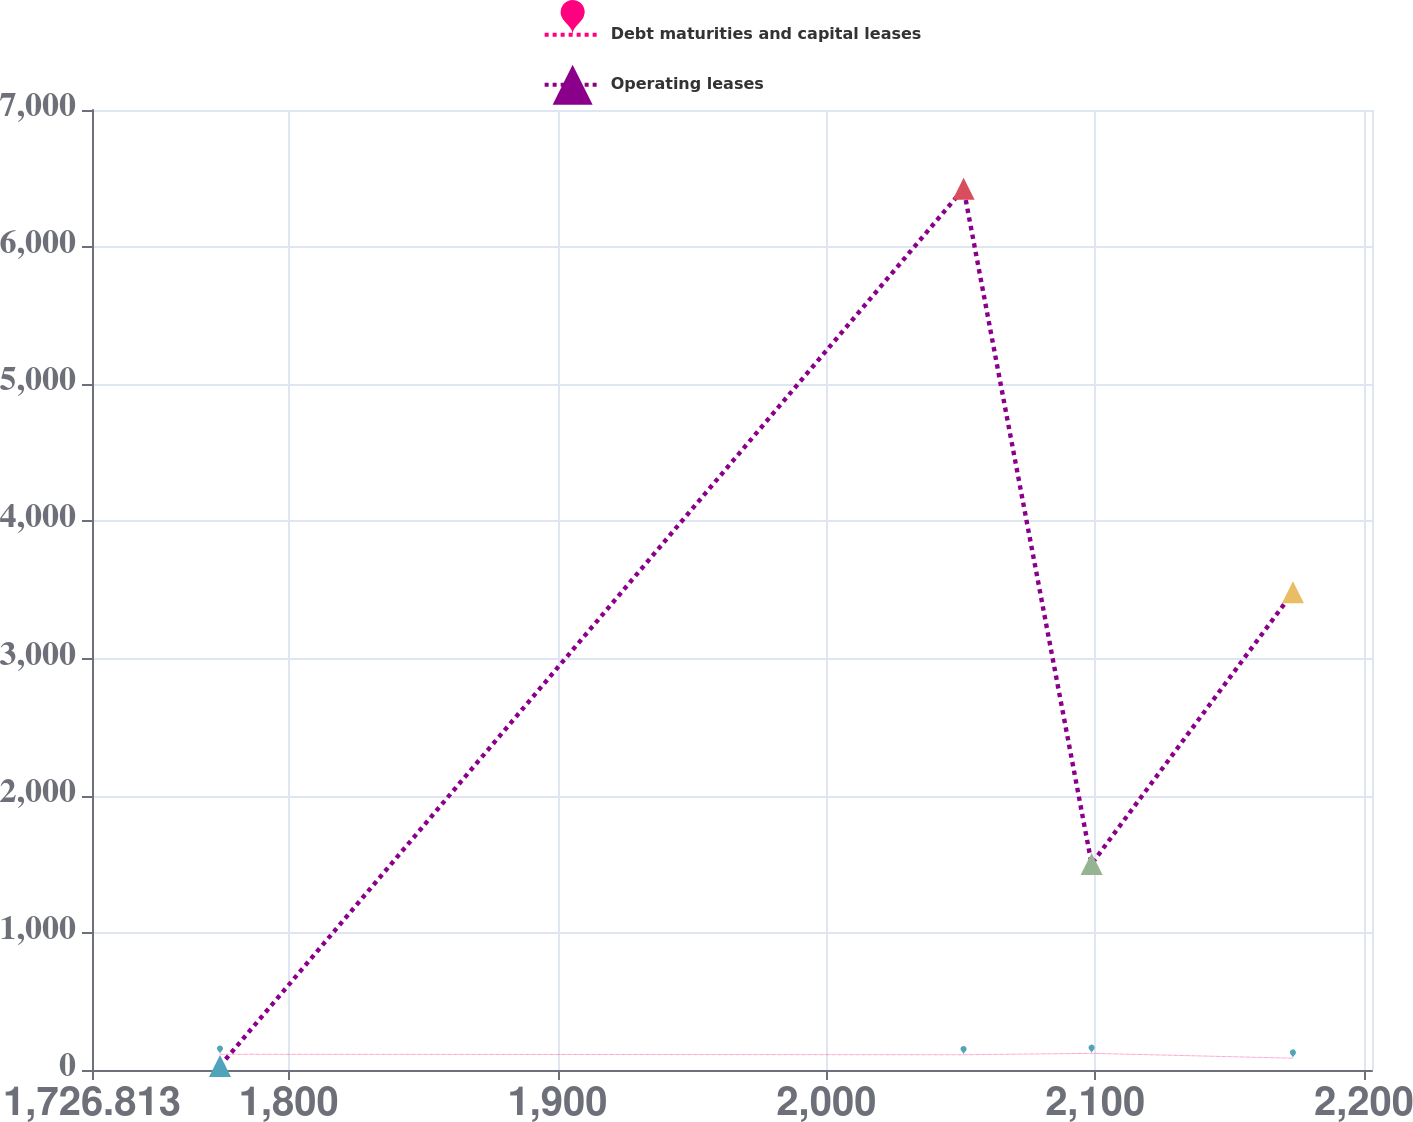Convert chart to OTSL. <chart><loc_0><loc_0><loc_500><loc_500><line_chart><ecel><fcel>Debt maturities and capital leases<fcel>Operating leases<nl><fcel>1774.43<fcel>114.8<fcel>29.42<nl><fcel>2051.06<fcel>111.26<fcel>6426.44<nl><fcel>2098.68<fcel>121.49<fcel>1502.6<nl><fcel>2173.58<fcel>86.11<fcel>3483.05<nl><fcel>2250.6<fcel>89.65<fcel>2142.3<nl></chart> 